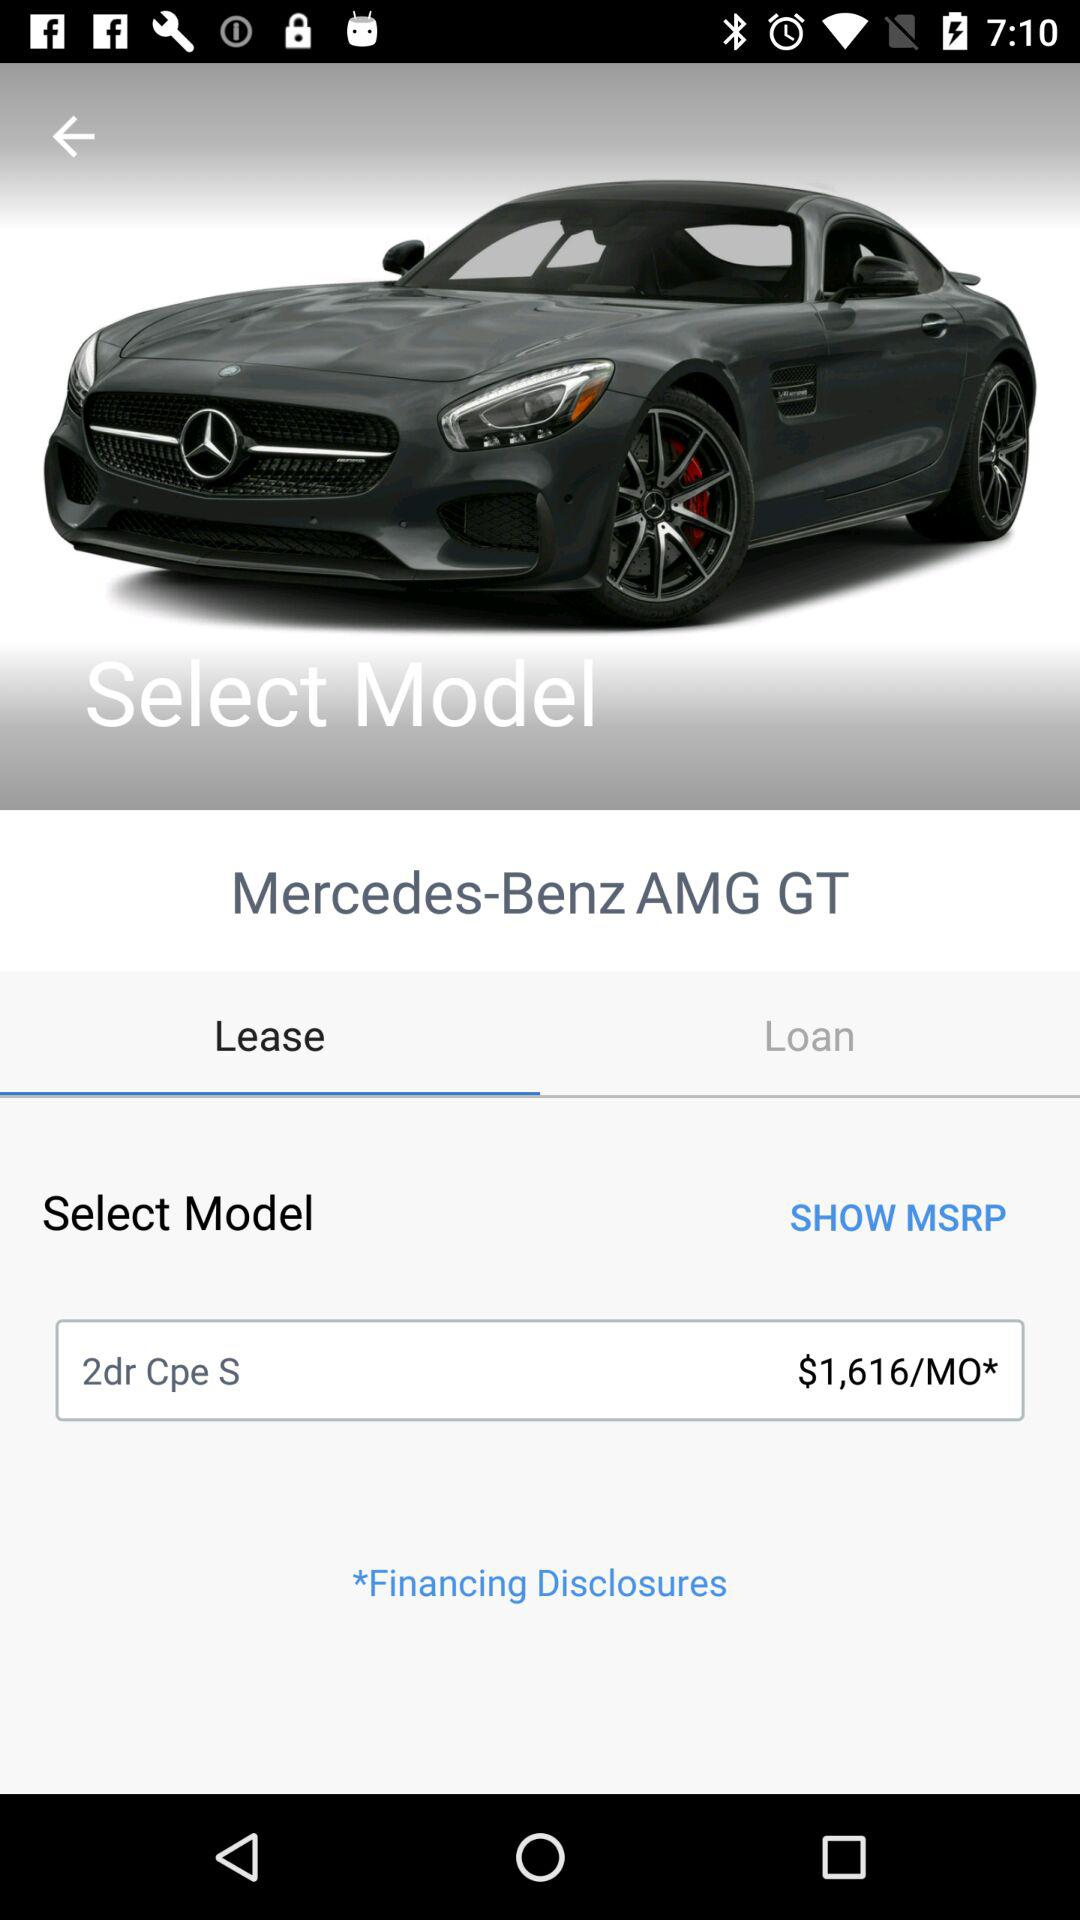What's the MSRP?
When the provided information is insufficient, respond with <no answer>. <no answer> 